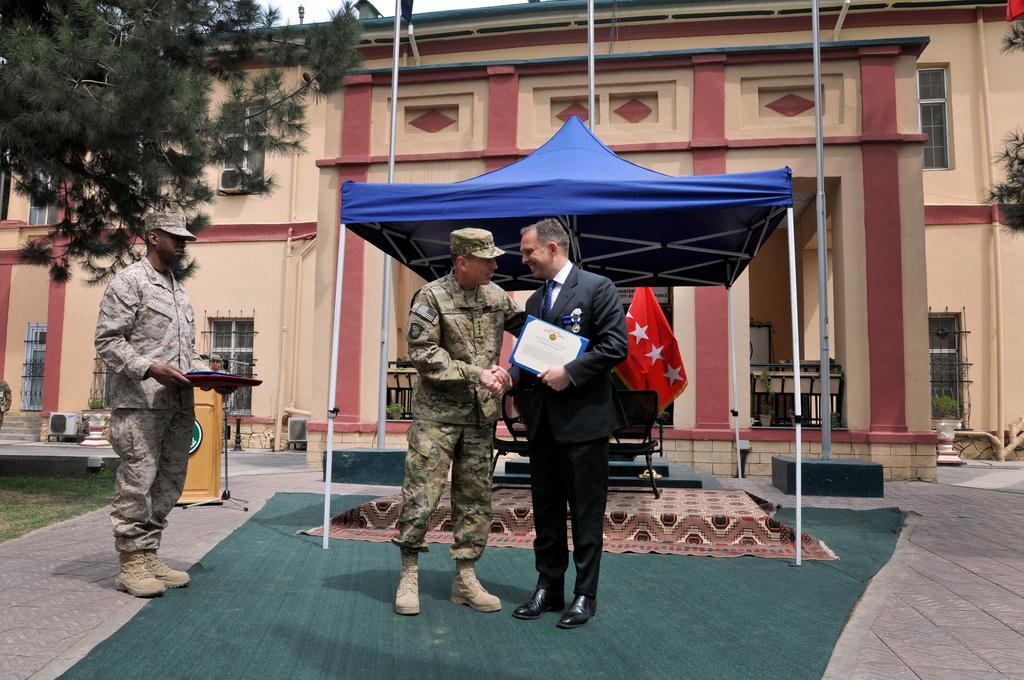In one or two sentences, can you explain what this image depicts? In the image there is a man in camouflage dress shaking hand with a man in suit standing on floor with carpet on it and behind them there is tent with flags in it and another person standing on the left side holding a tray, over the background there is a building with trees on either side. 